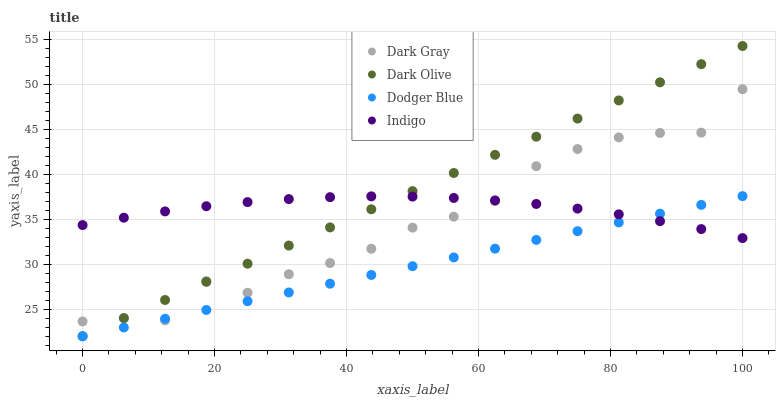Does Dodger Blue have the minimum area under the curve?
Answer yes or no. Yes. Does Dark Olive have the maximum area under the curve?
Answer yes or no. Yes. Does Indigo have the minimum area under the curve?
Answer yes or no. No. Does Indigo have the maximum area under the curve?
Answer yes or no. No. Is Dodger Blue the smoothest?
Answer yes or no. Yes. Is Dark Gray the roughest?
Answer yes or no. Yes. Is Indigo the smoothest?
Answer yes or no. No. Is Indigo the roughest?
Answer yes or no. No. Does Dark Olive have the lowest value?
Answer yes or no. Yes. Does Indigo have the lowest value?
Answer yes or no. No. Does Dark Olive have the highest value?
Answer yes or no. Yes. Does Indigo have the highest value?
Answer yes or no. No. Does Indigo intersect Dark Gray?
Answer yes or no. Yes. Is Indigo less than Dark Gray?
Answer yes or no. No. Is Indigo greater than Dark Gray?
Answer yes or no. No. 